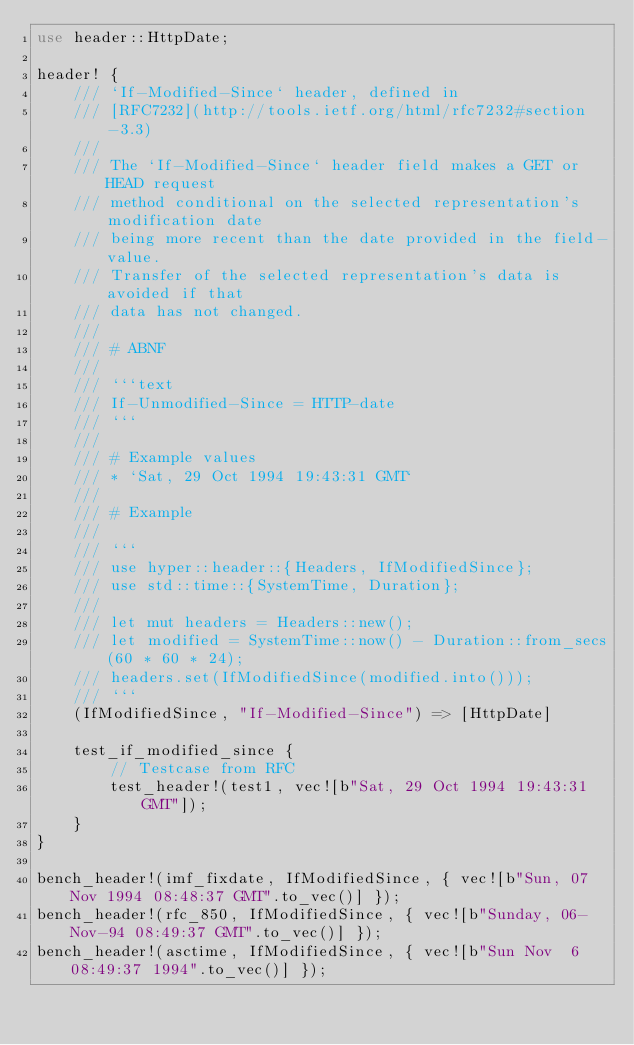<code> <loc_0><loc_0><loc_500><loc_500><_Rust_>use header::HttpDate;

header! {
    /// `If-Modified-Since` header, defined in
    /// [RFC7232](http://tools.ietf.org/html/rfc7232#section-3.3)
    ///
    /// The `If-Modified-Since` header field makes a GET or HEAD request
    /// method conditional on the selected representation's modification date
    /// being more recent than the date provided in the field-value.
    /// Transfer of the selected representation's data is avoided if that
    /// data has not changed.
    ///
    /// # ABNF
    ///
    /// ```text
    /// If-Unmodified-Since = HTTP-date
    /// ```
    ///
    /// # Example values
    /// * `Sat, 29 Oct 1994 19:43:31 GMT`
    ///
    /// # Example
    ///
    /// ```
    /// use hyper::header::{Headers, IfModifiedSince};
    /// use std::time::{SystemTime, Duration};
    ///
    /// let mut headers = Headers::new();
    /// let modified = SystemTime::now() - Duration::from_secs(60 * 60 * 24);
    /// headers.set(IfModifiedSince(modified.into()));
    /// ```
    (IfModifiedSince, "If-Modified-Since") => [HttpDate]

    test_if_modified_since {
        // Testcase from RFC
        test_header!(test1, vec![b"Sat, 29 Oct 1994 19:43:31 GMT"]);
    }
}

bench_header!(imf_fixdate, IfModifiedSince, { vec![b"Sun, 07 Nov 1994 08:48:37 GMT".to_vec()] });
bench_header!(rfc_850, IfModifiedSince, { vec![b"Sunday, 06-Nov-94 08:49:37 GMT".to_vec()] });
bench_header!(asctime, IfModifiedSince, { vec![b"Sun Nov  6 08:49:37 1994".to_vec()] });
</code> 